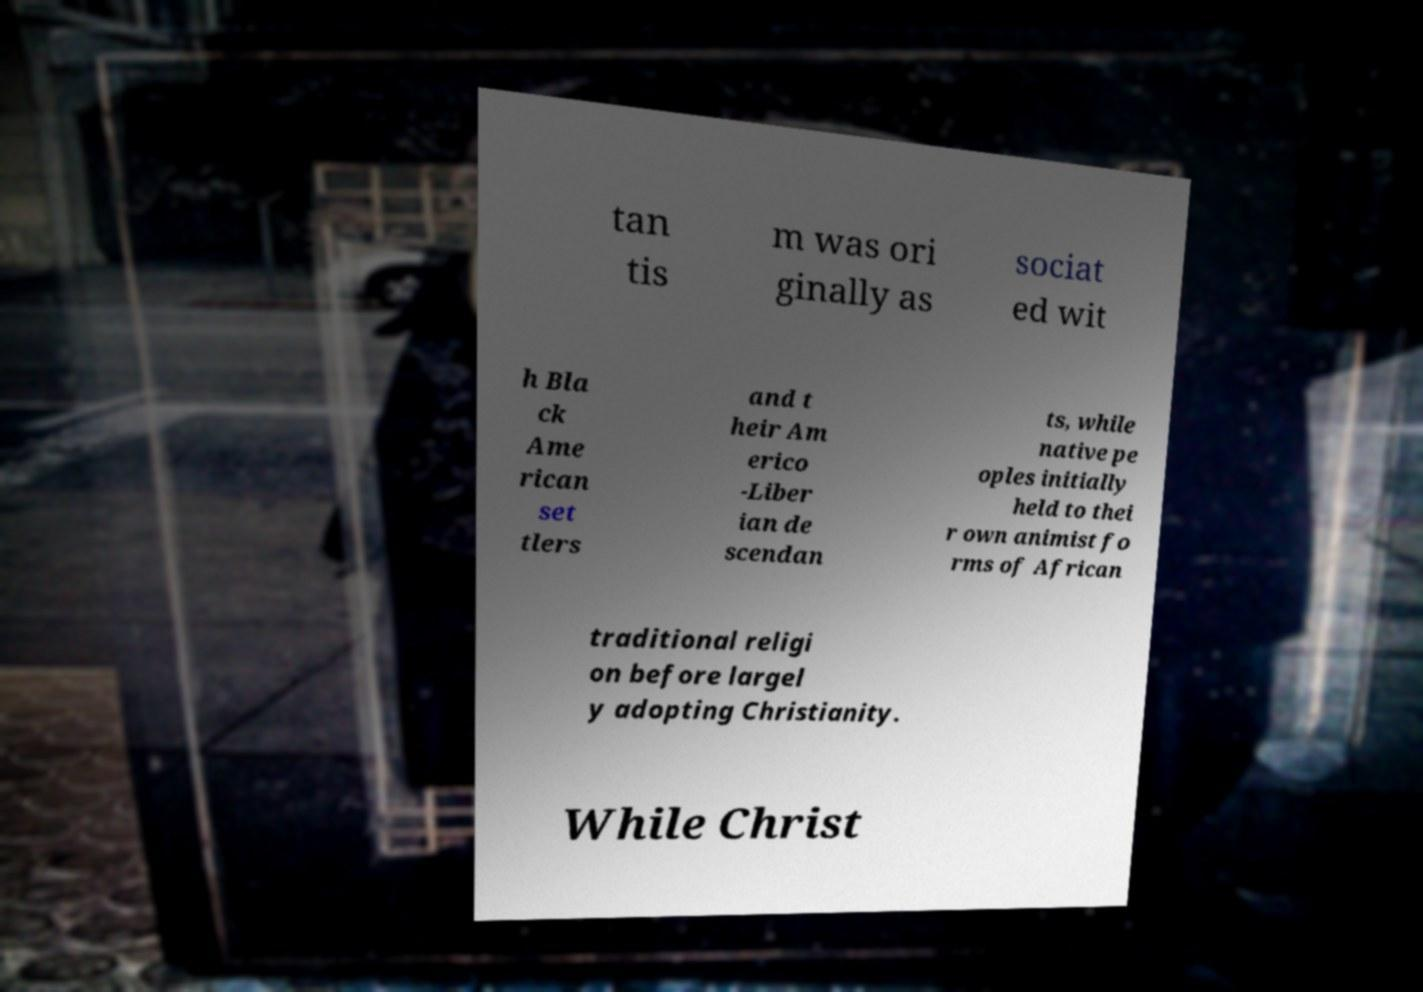Can you accurately transcribe the text from the provided image for me? tan tis m was ori ginally as sociat ed wit h Bla ck Ame rican set tlers and t heir Am erico -Liber ian de scendan ts, while native pe oples initially held to thei r own animist fo rms of African traditional religi on before largel y adopting Christianity. While Christ 